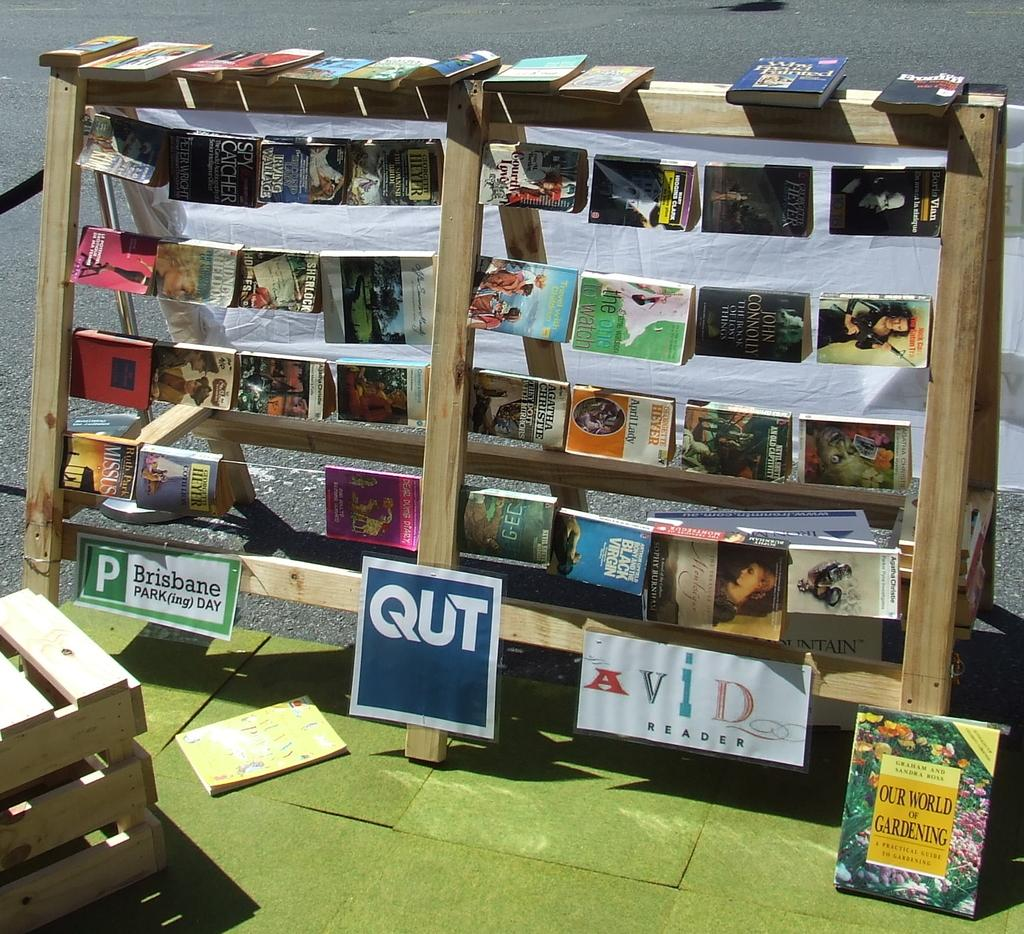<image>
Share a concise interpretation of the image provided. outdoor wooden display of books for brisbane park(ing) day 